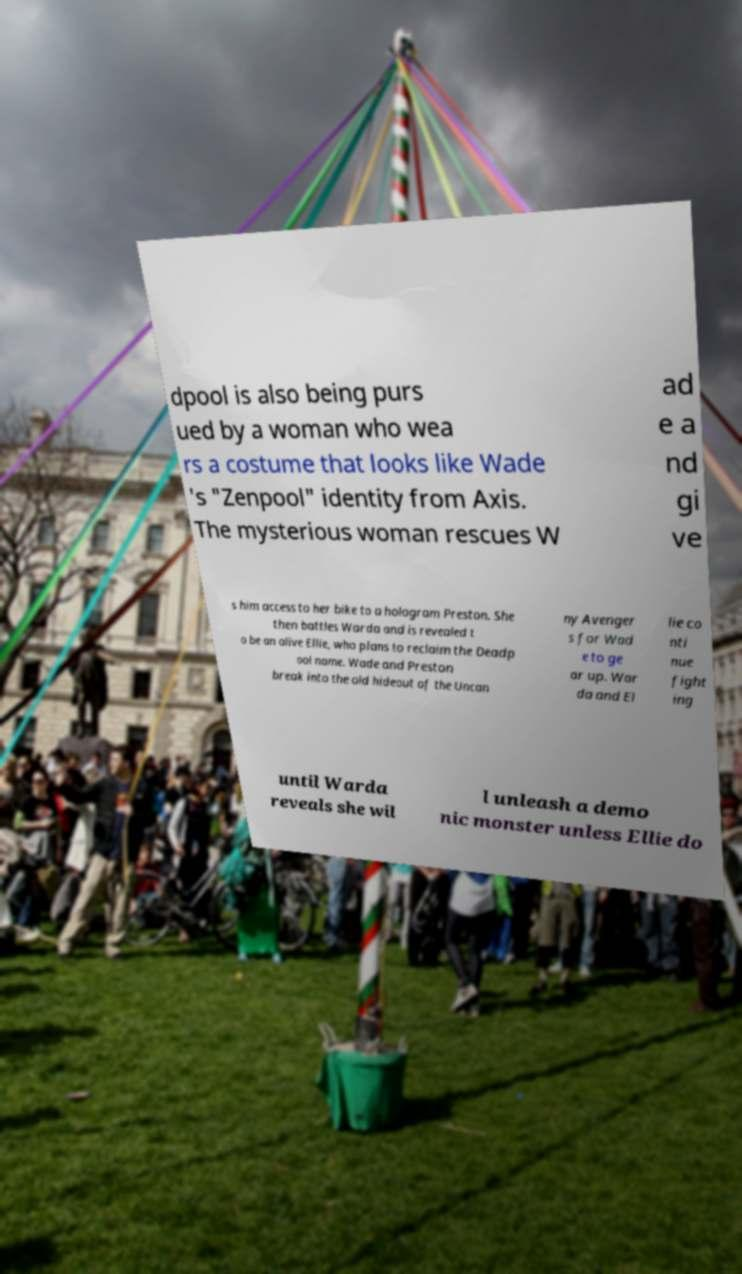Can you read and provide the text displayed in the image?This photo seems to have some interesting text. Can you extract and type it out for me? dpool is also being purs ued by a woman who wea rs a costume that looks like Wade 's "Zenpool" identity from Axis. The mysterious woman rescues W ad e a nd gi ve s him access to her bike to a hologram Preston. She then battles Warda and is revealed t o be an alive Ellie, who plans to reclaim the Deadp ool name. Wade and Preston break into the old hideout of the Uncan ny Avenger s for Wad e to ge ar up. War da and El lie co nti nue fight ing until Warda reveals she wil l unleash a demo nic monster unless Ellie do 